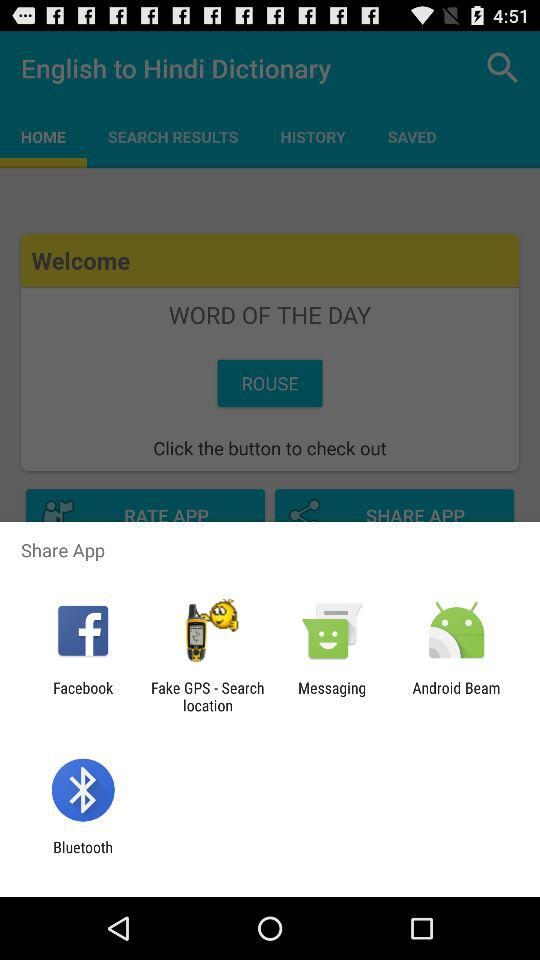What is the translation of the word "ROUSE"?
When the provided information is insufficient, respond with <no answer>. <no answer> 